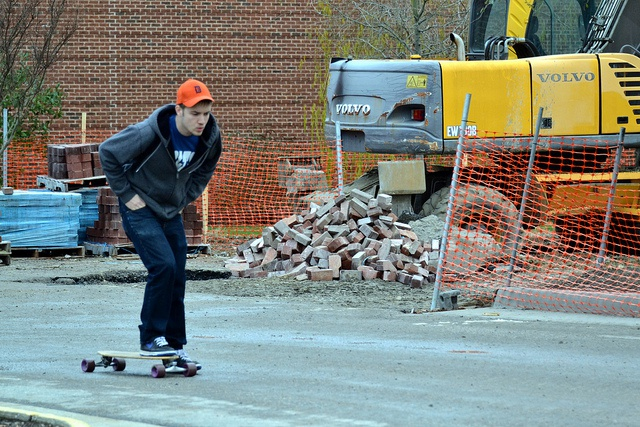Describe the objects in this image and their specific colors. I can see people in gray, black, navy, blue, and darkgray tones and skateboard in gray, black, and lightblue tones in this image. 